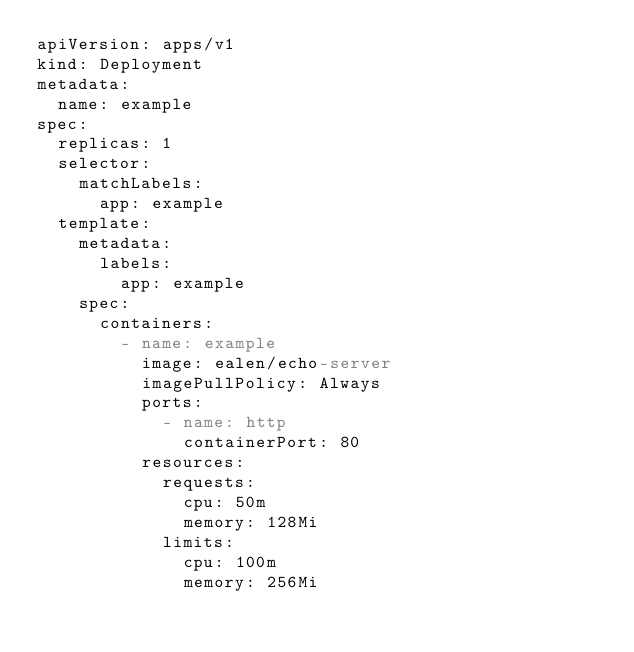Convert code to text. <code><loc_0><loc_0><loc_500><loc_500><_YAML_>apiVersion: apps/v1
kind: Deployment
metadata:
  name: example
spec:
  replicas: 1
  selector:
    matchLabels:
      app: example
  template:
    metadata:
      labels:
        app: example
    spec:
      containers:
        - name: example
          image: ealen/echo-server
          imagePullPolicy: Always
          ports:
            - name: http
              containerPort: 80
          resources:
            requests:
              cpu: 50m
              memory: 128Mi
            limits:
              cpu: 100m
              memory: 256Mi</code> 